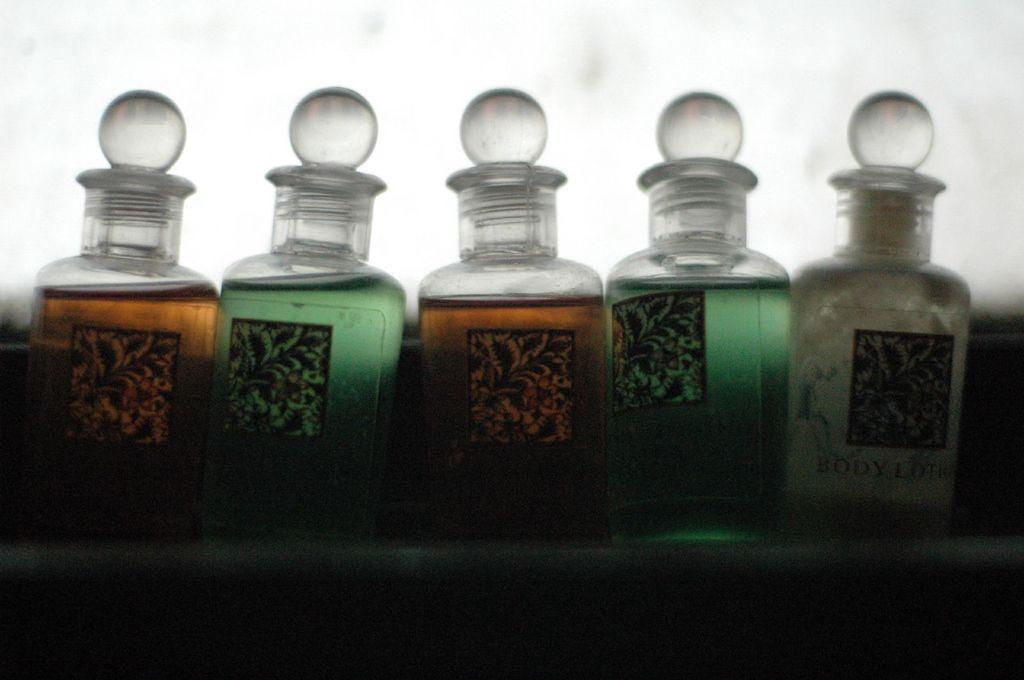<image>
Offer a succinct explanation of the picture presented. five different colored bottles with orange and green liquids in alternating sequence. 